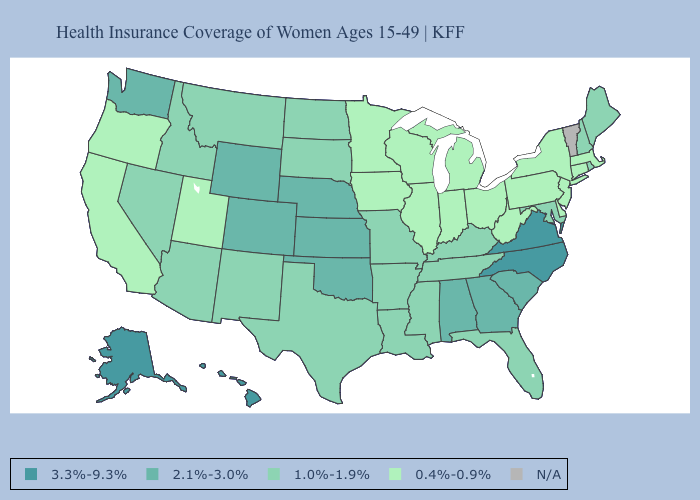Does the map have missing data?
Keep it brief. Yes. Name the states that have a value in the range 1.0%-1.9%?
Keep it brief. Arizona, Arkansas, Florida, Idaho, Kentucky, Louisiana, Maine, Maryland, Mississippi, Missouri, Montana, Nevada, New Hampshire, New Mexico, North Dakota, Rhode Island, South Dakota, Tennessee, Texas. Name the states that have a value in the range 3.3%-9.3%?
Keep it brief. Alaska, Hawaii, North Carolina, Virginia. What is the lowest value in states that border Ohio?
Keep it brief. 0.4%-0.9%. What is the highest value in states that border Colorado?
Be succinct. 2.1%-3.0%. Does Illinois have the highest value in the MidWest?
Quick response, please. No. Does the first symbol in the legend represent the smallest category?
Quick response, please. No. Does the first symbol in the legend represent the smallest category?
Write a very short answer. No. Name the states that have a value in the range 3.3%-9.3%?
Short answer required. Alaska, Hawaii, North Carolina, Virginia. Name the states that have a value in the range N/A?
Be succinct. Vermont. What is the value of Nebraska?
Give a very brief answer. 2.1%-3.0%. What is the lowest value in the West?
Be succinct. 0.4%-0.9%. Name the states that have a value in the range 2.1%-3.0%?
Answer briefly. Alabama, Colorado, Georgia, Kansas, Nebraska, Oklahoma, South Carolina, Washington, Wyoming. 